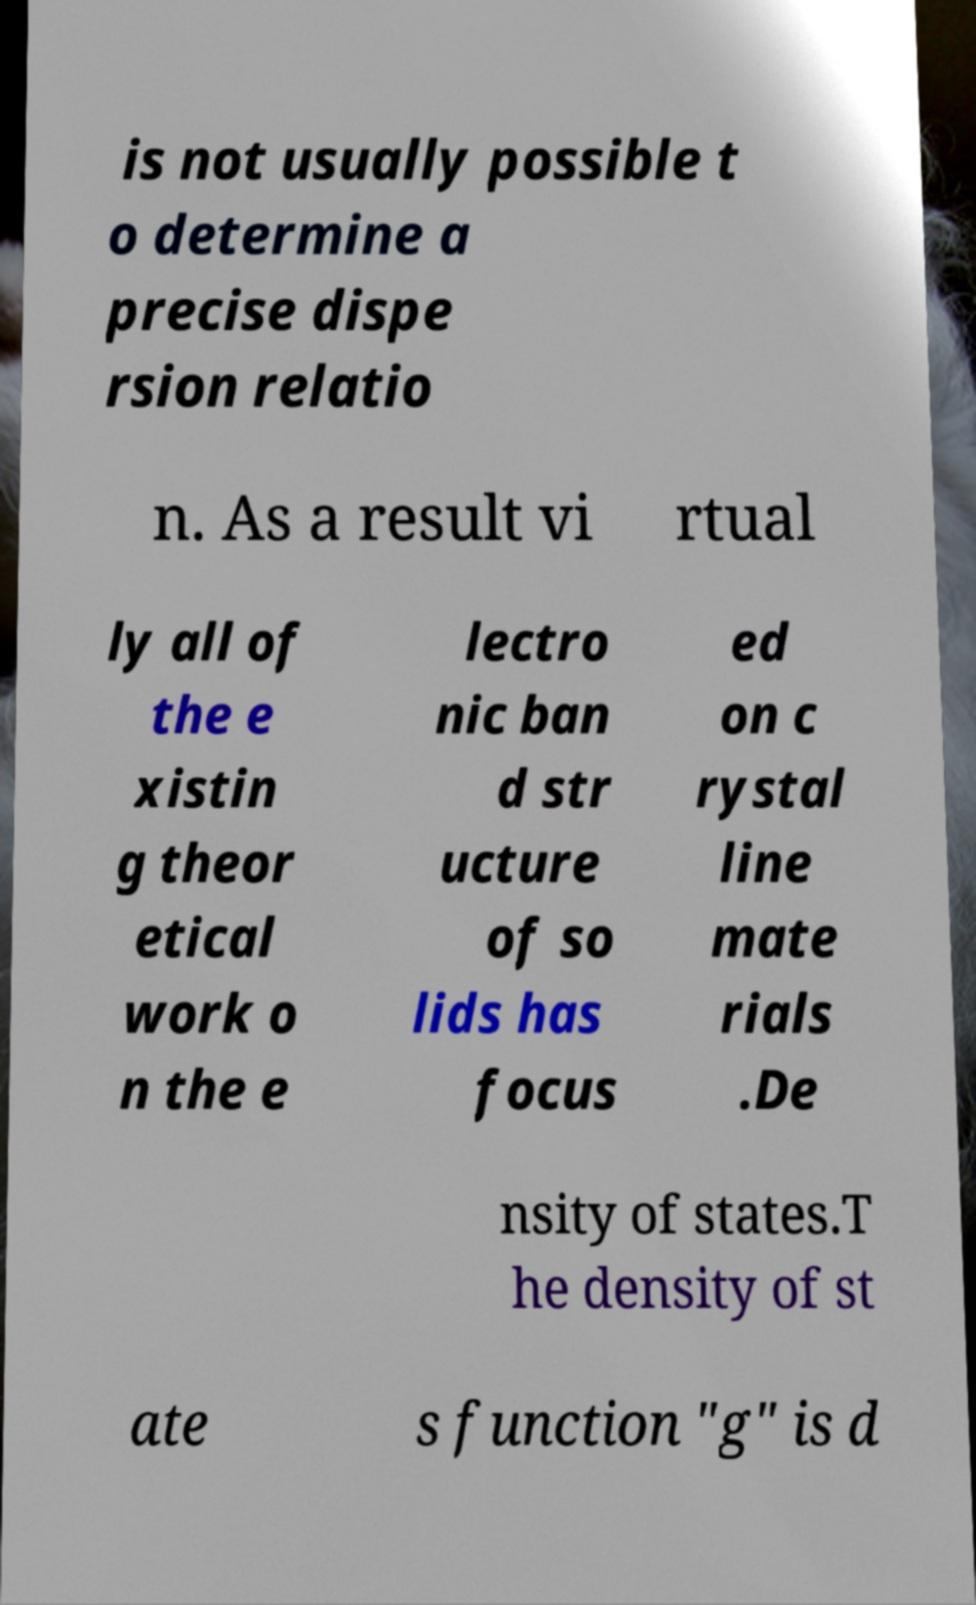Could you assist in decoding the text presented in this image and type it out clearly? is not usually possible t o determine a precise dispe rsion relatio n. As a result vi rtual ly all of the e xistin g theor etical work o n the e lectro nic ban d str ucture of so lids has focus ed on c rystal line mate rials .De nsity of states.T he density of st ate s function "g" is d 